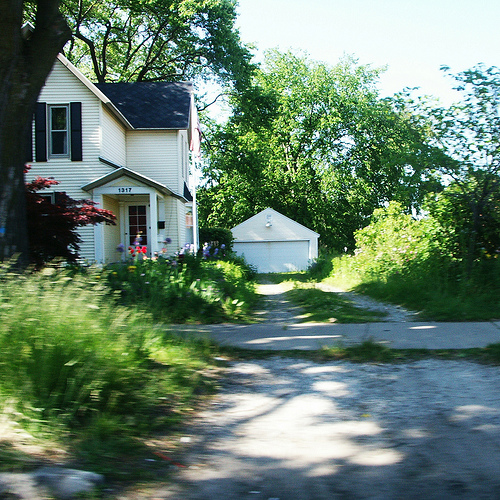<image>
Can you confirm if the house is in front of the garage? Yes. The house is positioned in front of the garage, appearing closer to the camera viewpoint. 